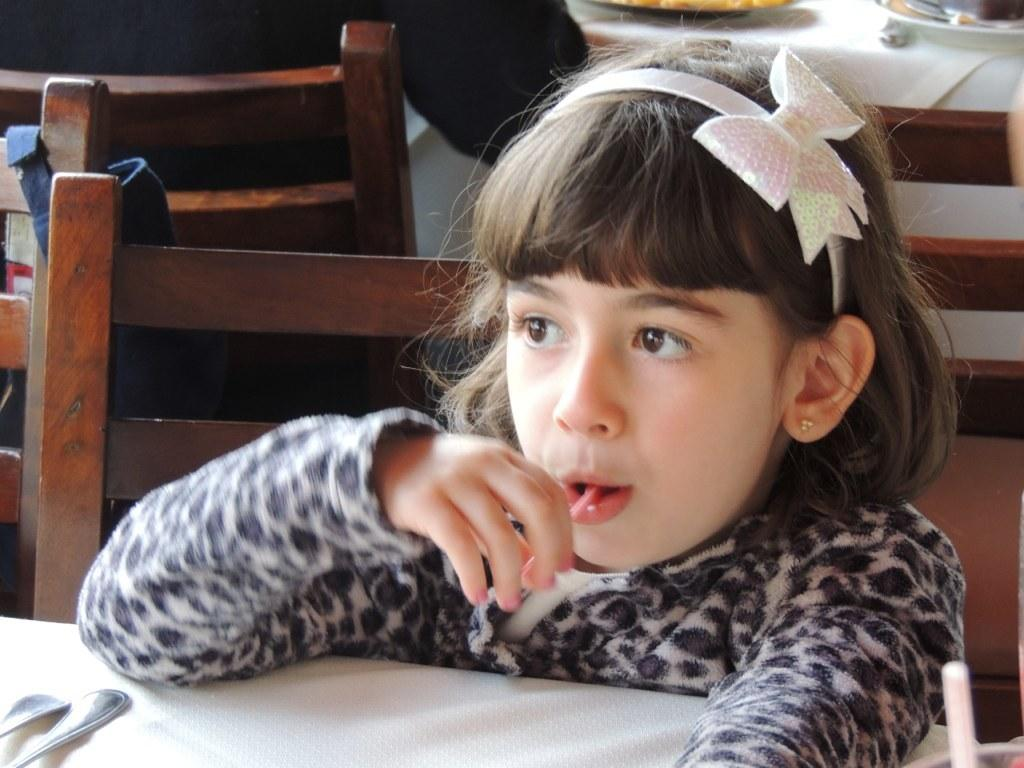Who is the main subject in the image? There is a girl in the image. What is the girl doing in the image? The girl is sitting on a chair. What type of slave is depicted in the image? There is no depiction of a slave in the image; it features a girl sitting on a chair. What committee does the girl belong to in the image? There is no mention of a committee or any affiliation in the image; it simply shows a girl sitting on a chair. 